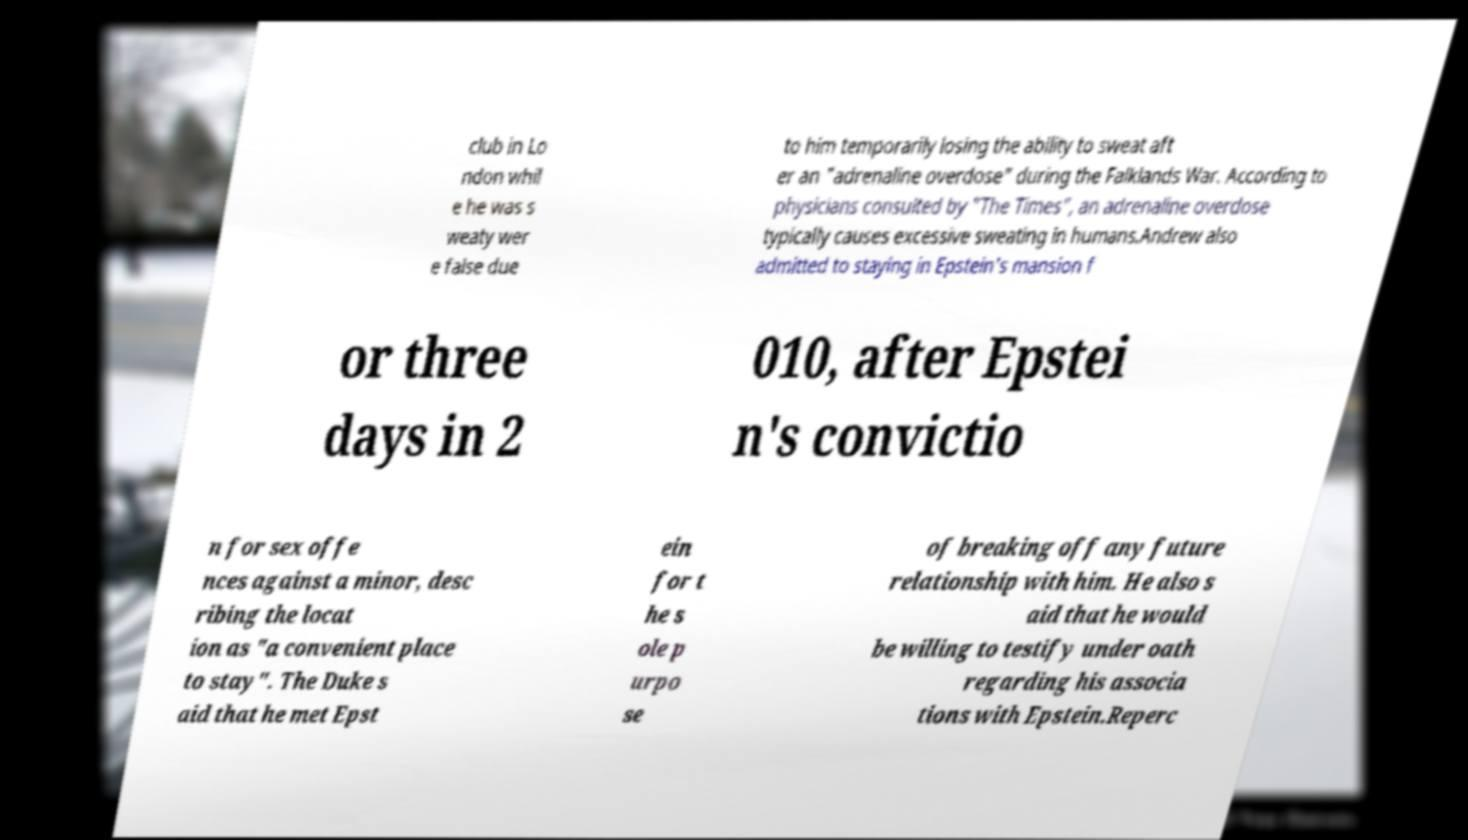There's text embedded in this image that I need extracted. Can you transcribe it verbatim? club in Lo ndon whil e he was s weaty wer e false due to him temporarily losing the ability to sweat aft er an "adrenaline overdose" during the Falklands War. According to physicians consulted by "The Times", an adrenaline overdose typically causes excessive sweating in humans.Andrew also admitted to staying in Epstein's mansion f or three days in 2 010, after Epstei n's convictio n for sex offe nces against a minor, desc ribing the locat ion as "a convenient place to stay". The Duke s aid that he met Epst ein for t he s ole p urpo se of breaking off any future relationship with him. He also s aid that he would be willing to testify under oath regarding his associa tions with Epstein.Reperc 